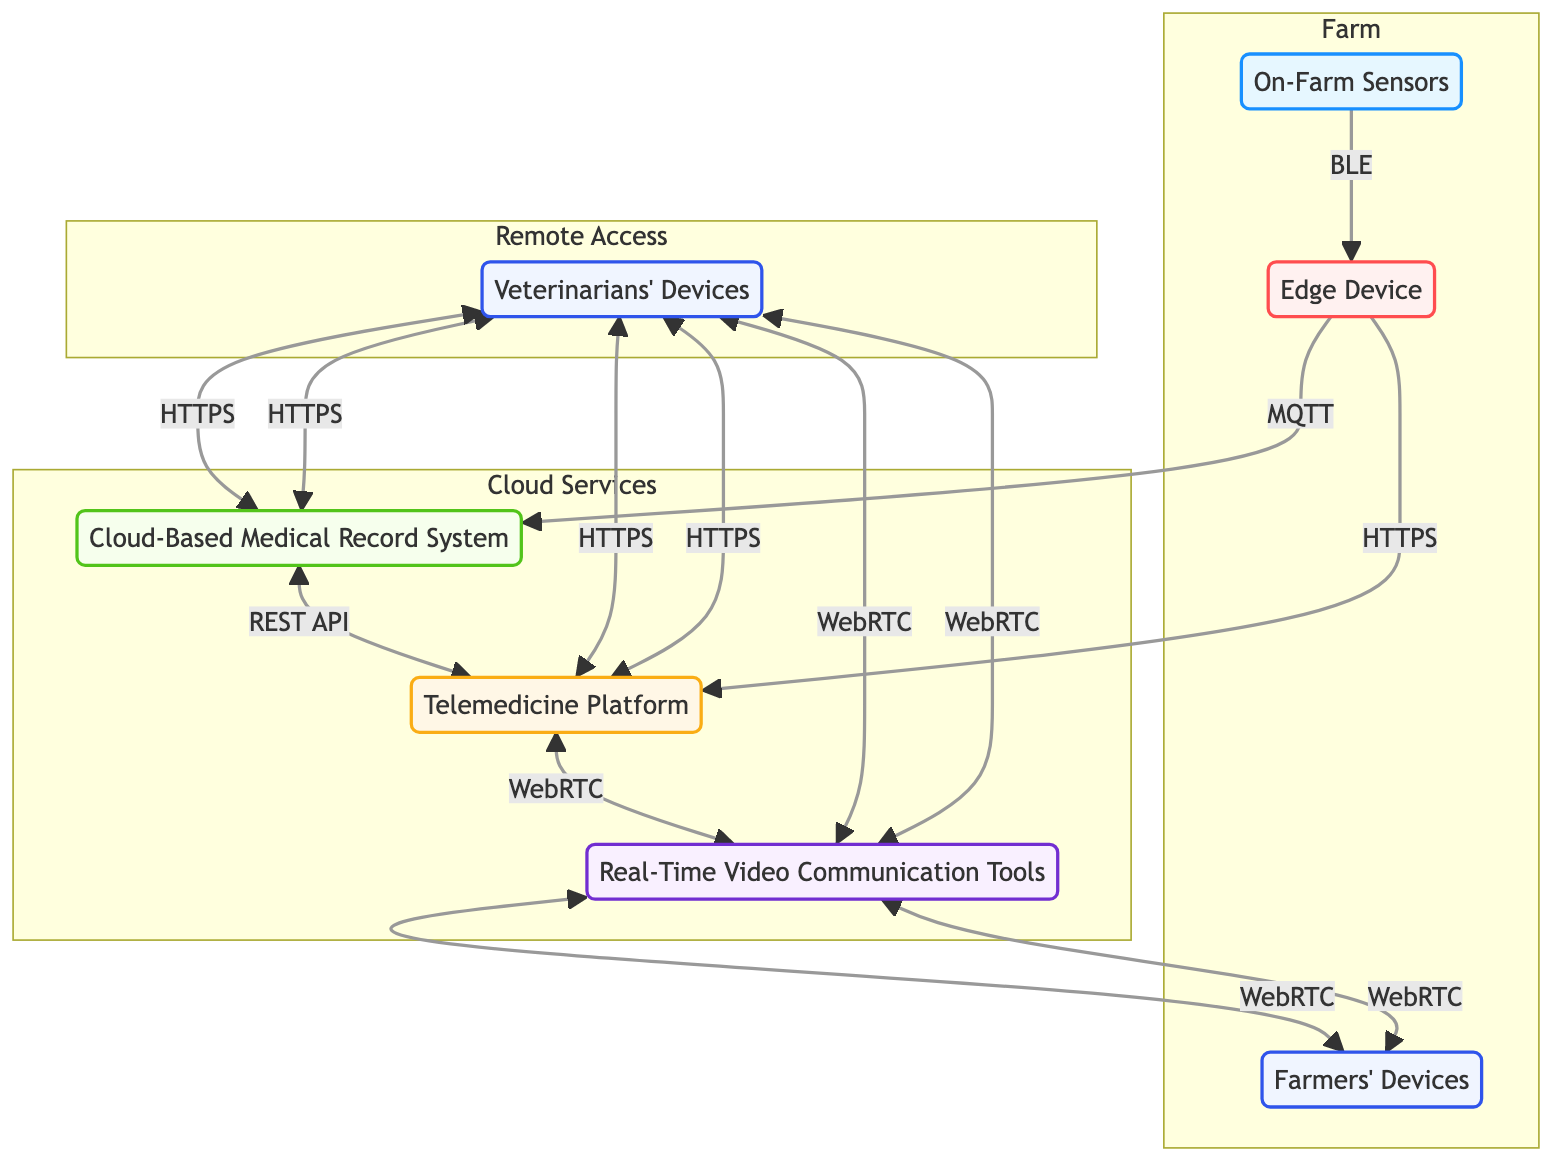What is the type of the On-Farm Sensors node? The On-Farm Sensors node is classified as "Sensor Nodes," according to its description in the diagram.
Answer: Sensor Nodes How many total nodes are depicted in the diagram? The diagram presents a total of seven nodes: On-Farm Sensors, Edge Device, Cloud-Based Medical Record System, Telemedicine Platform, Real-Time Video Communication Tools, Veterinarians' Devices, and Farmers' Devices.
Answer: Seven What protocol is used to connect the Edge Device to the Cloud-Based Medical Record System? The connection from the Edge Device to the Cloud-Based Medical Record System employs the MQTT protocol, as indicated by the connections in the diagram.
Answer: MQTT Which node connects to the Real-Time Video Communication Tools? The Telemedicine Platform connects to the Real-Time Video Communication Tools, as shown in the connections noted on the diagram.
Answer: Telemedicine Platform What type of communication allows veterinarians to receive real-time video from farmers? The real-time video is facilitated by the WebRTC protocol, which is shown as the connection type between the Real-Time Video Communication Tools and Veterinarians' Devices.
Answer: WebRTC Which devices can farmers use to initiate video calls with veterinarians? Farmers can use Farmers' Devices to initiate video calls, as the connection from Farmers' Devices to Real-Time Video Communication Tools is specifically noted in the diagram.
Answer: Farmers' Devices How many connections are there from the Veterinarians' Devices? There are three connections originating from the Veterinarians' Devices to the Cloud-Based Medical Record System, Telemedicine Platform, and Real-Time Video Communication Tools in the diagram.
Answer: Three What type of platform is the Telemedicine Platform classified as? The Telemedicine Platform is categorized as a "Service Interface" in the diagram, representing its role in remote veterinary assistance.
Answer: Service Interface What enables the Edge Device to send data for immediate analysis? The protocol enabling the Edge Device to send data for immediate analysis to the Telemedicine Platform is HTTPS, clearly indicated in the connections section of the diagram.
Answer: HTTPS 